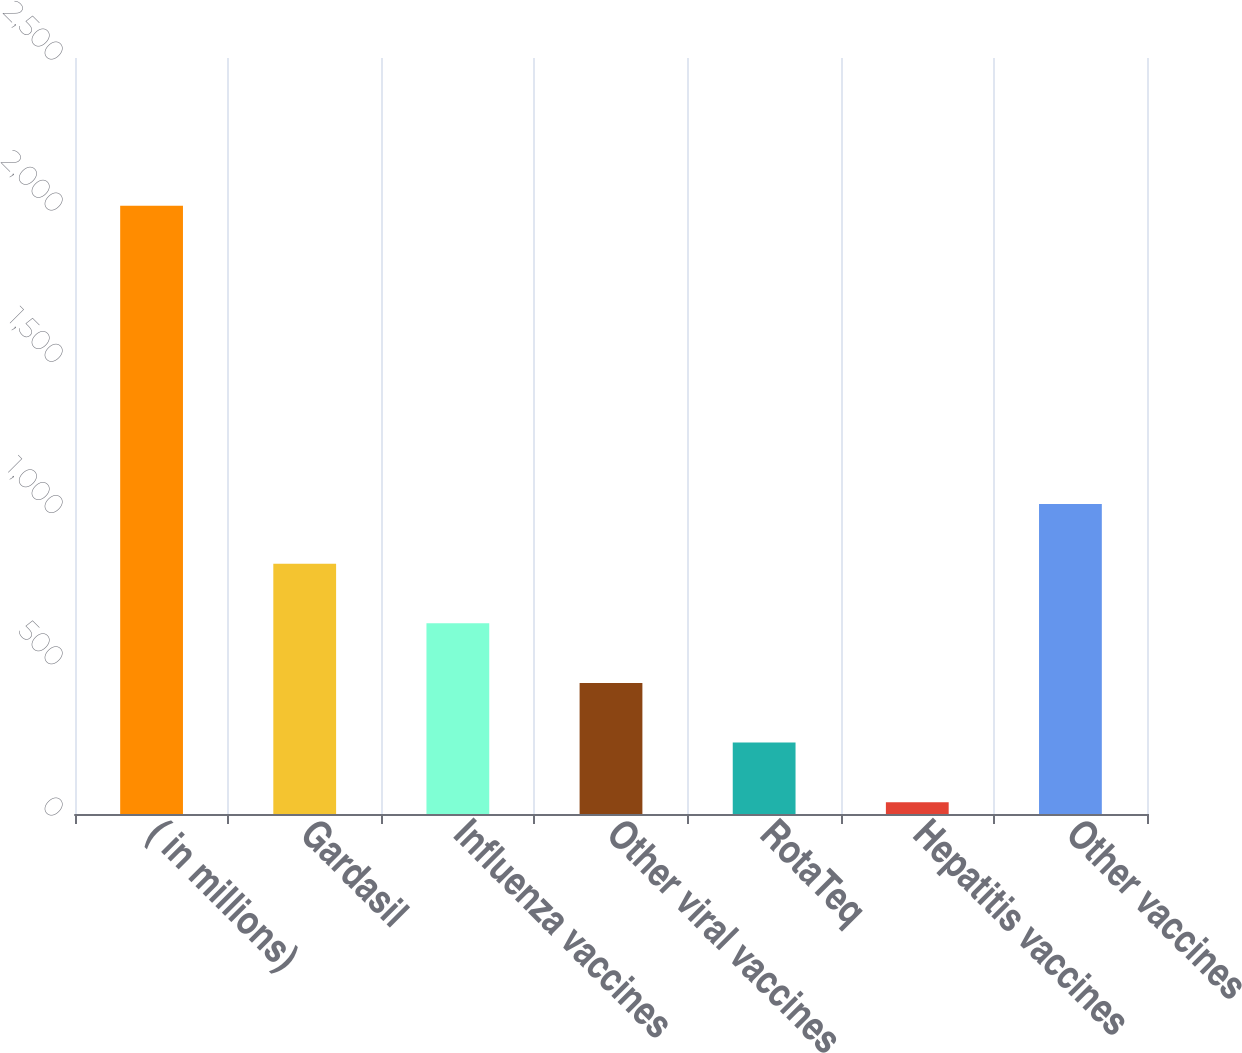Convert chart. <chart><loc_0><loc_0><loc_500><loc_500><bar_chart><fcel>( in millions)<fcel>Gardasil<fcel>Influenza vaccines<fcel>Other viral vaccines<fcel>RotaTeq<fcel>Hepatitis vaccines<fcel>Other vaccines<nl><fcel>2011<fcel>827.8<fcel>630.6<fcel>433.4<fcel>236.2<fcel>39<fcel>1025<nl></chart> 